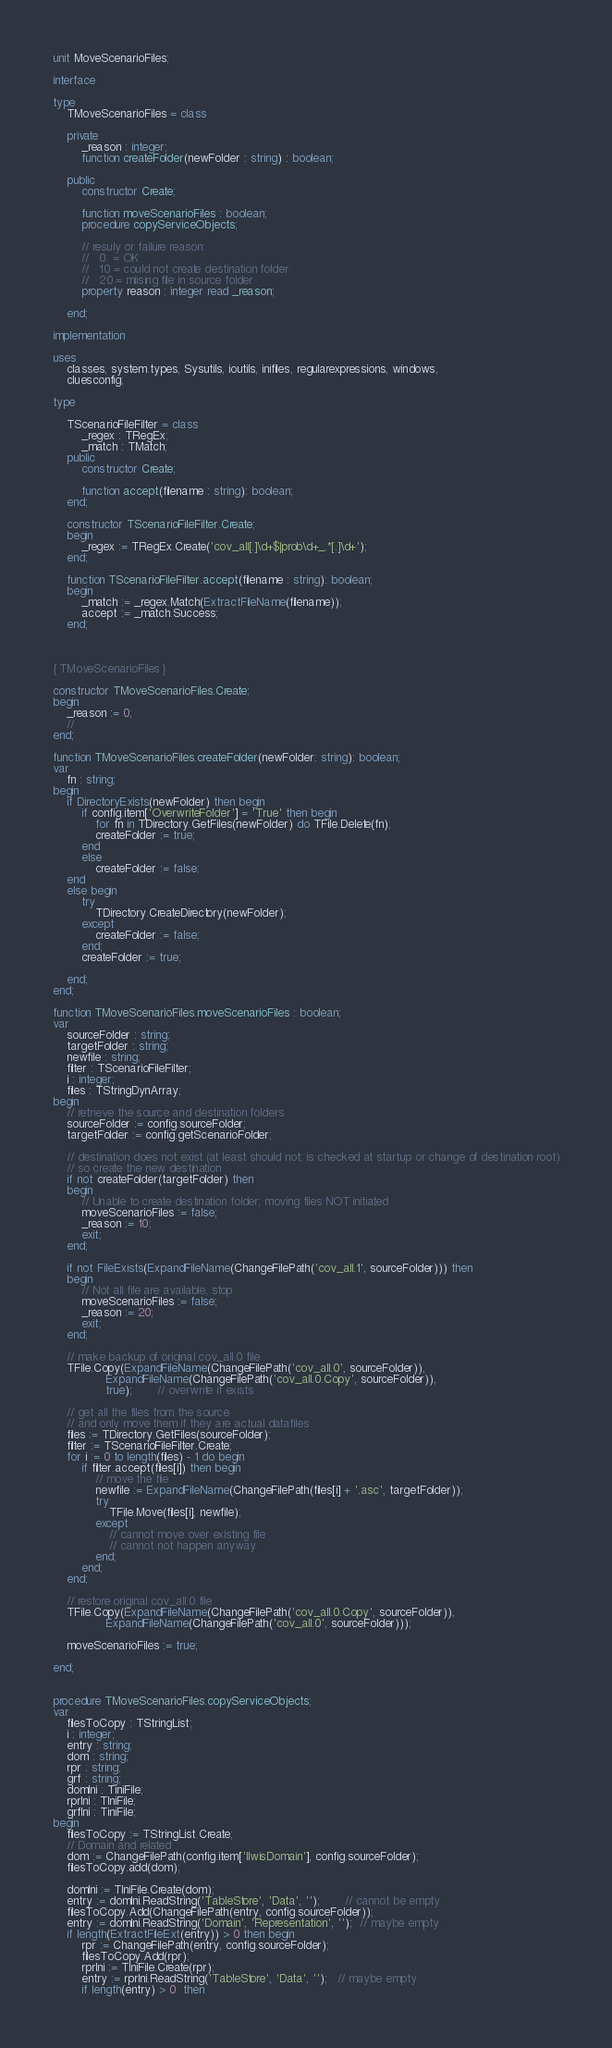<code> <loc_0><loc_0><loc_500><loc_500><_Pascal_>unit MoveScenarioFiles;

interface

type
    TMoveScenarioFiles = class

	private
        _reason : integer;
        function createFolder(newFolder : string) : boolean;

	public
        constructor Create;

        function moveScenarioFiles : boolean;
        procedure copyServiceObjects;

        // resuly or failure reason:
        //   0  = OK
        //   10 = could not create destination folder
        //   20 = miising file in source folder
        property reason : integer read _reason;

    end;

implementation

uses
    classes, system.types, Sysutils, ioutils, inifiles, regularexpressions, windows,
    cluesconfig;

type

	TScenarioFileFilter = class
        _regex : TRegEx;
        _match : TMatch;
    public
        constructor Create;

        function accept(filename : string): boolean;
    end;

    constructor TScenarioFileFilter.Create;
    begin
        _regex := TRegEx.Create('cov_all[.]\d+$|prob\d+_.*[.]\d+');
    end;

    function TScenarioFileFilter.accept(filename : string): boolean;
    begin
        _match := _regex.Match(ExtractFileName(filename));
        accept := _match.Success;
    end;



{ TMoveScenarioFiles }

constructor TMoveScenarioFiles.Create;
begin
    _reason := 0;
    //
end;

function TMoveScenarioFiles.createFolder(newFolder: string): boolean;
var
    fn : string;
begin
    if DirectoryExists(newFolder) then begin
        if config.item['OverwriteFolder'] = 'True' then begin
            for fn in TDirectory.GetFiles(newFolder) do TFile.Delete(fn);
            createFolder := true;
        end
        else
            createFolder := false;
    end
    else begin
        try
            TDirectory.CreateDirectory(newFolder);
        except
    		createFolder := false;
        end;
		createFolder := true;

    end;
end;

function TMoveScenarioFiles.moveScenarioFiles : boolean;
var
    sourceFolder : string;
    targetFolder : string;
    newfile : string;
    filter : TScenarioFileFilter;
    i : integer;
    files : TStringDynArray;
begin
    // retrieve the source and destination folders
    sourceFolder := config.sourceFolder;
    targetFolder := config.getScenarioFolder;

    // destination does not exist (at least should not; is checked at startup or change of destination root)
    // so create the new destination
    if not createFolder(targetFolder) then
    begin
        // Unable to create destination folder; moving files NOT initiated
        moveScenarioFiles := false;
        _reason := 10;
        exit;
    end;

    if not FileExists(ExpandFileName(ChangeFilePath('cov_all.1', sourceFolder))) then
    begin
        // Not all file are available, stop
        moveScenarioFiles := false;
        _reason := 20;
        exit;
    end;

    // make backup of original cov_all.0 file
    TFile.Copy(ExpandFileName(ChangeFilePath('cov_all.0', sourceFolder)),
               ExpandFileName(ChangeFilePath('cov_all.0.Copy', sourceFolder)),
               true);       // overwrite if exists

    // get all the files from the source
    // and only move them if they are actual datafiles
    files := TDirectory.GetFiles(sourceFolder);
    filter := TScenarioFileFilter.Create;
    for i := 0 to length(files) - 1 do begin
        if filter.accept(files[i]) then begin
            // move the file
            newfile := ExpandFileName(ChangeFilePath(files[i] + '.asc', targetFolder));
            try
                TFile.Move(files[i], newfile);
            except
                // cannot move over existing file
                // cannot not happen anyway
            end;
        end;
    end;

    // restore original cov_all.0 file
    TFile.Copy(ExpandFileName(ChangeFilePath('cov_all.0.Copy', sourceFolder)),
               ExpandFileName(ChangeFilePath('cov_all.0', sourceFolder)));

    moveScenarioFiles := true;

end;


procedure TMoveScenarioFiles.copyServiceObjects;
var
    filesToCopy : TStringList;
    i : integer;
    entry : string;
    dom : string;
    rpr : string;
    grf : string;
    domIni : TiniFile;
    rprIni : TIniFile;
    grfIni : TiniFile;
begin
    filesToCopy := TStringList.Create;
    // Domain and related
    dom := ChangeFilePath(config.item['IlwisDomain'], config.sourceFolder);
    filesToCopy.add(dom);

    domIni := TIniFile.Create(dom);
    entry := domIni.ReadString('TableStore', 'Data', '');       // cannot be empty
    filesToCopy.Add(ChangeFilePath(entry, config.sourceFolder));
    entry := domIni.ReadString('Domain', 'Representation', '');  // maybe empty
    if length(ExtractFileExt(entry)) > 0 then begin
        rpr := ChangeFilePath(entry, config.sourceFolder);
        filesToCopy.Add(rpr);
        rprIni := TIniFile.Create(rpr);
        entry := rprIni.ReadString('TableStore', 'Data', '');   // maybe empty
        if length(entry) > 0  then</code> 